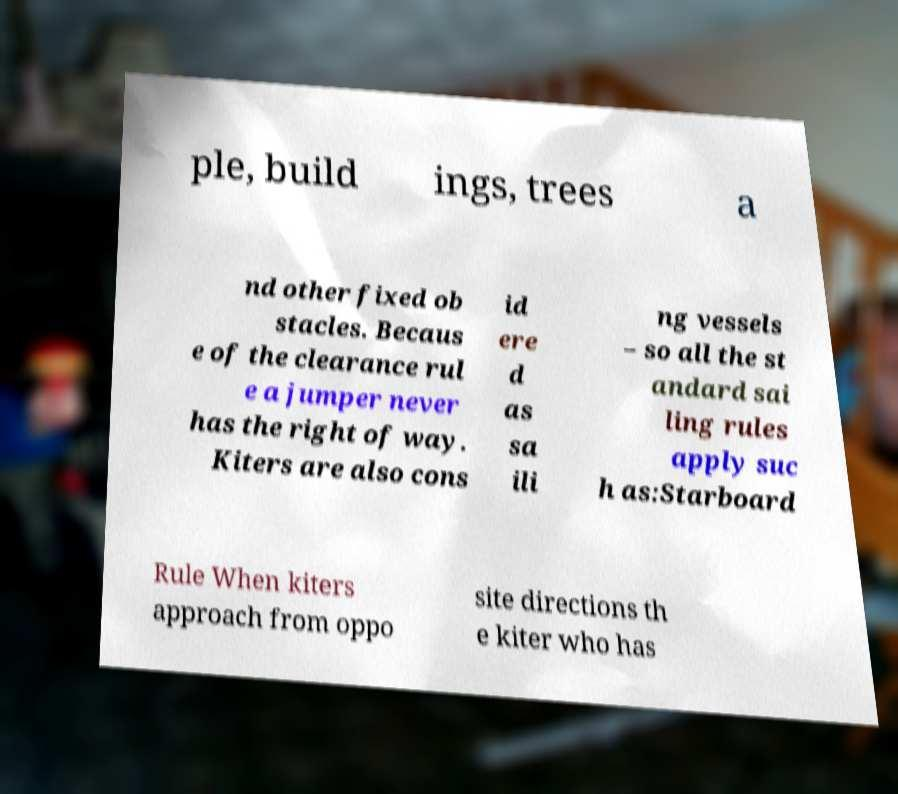For documentation purposes, I need the text within this image transcribed. Could you provide that? ple, build ings, trees a nd other fixed ob stacles. Becaus e of the clearance rul e a jumper never has the right of way. Kiters are also cons id ere d as sa ili ng vessels – so all the st andard sai ling rules apply suc h as:Starboard Rule When kiters approach from oppo site directions th e kiter who has 